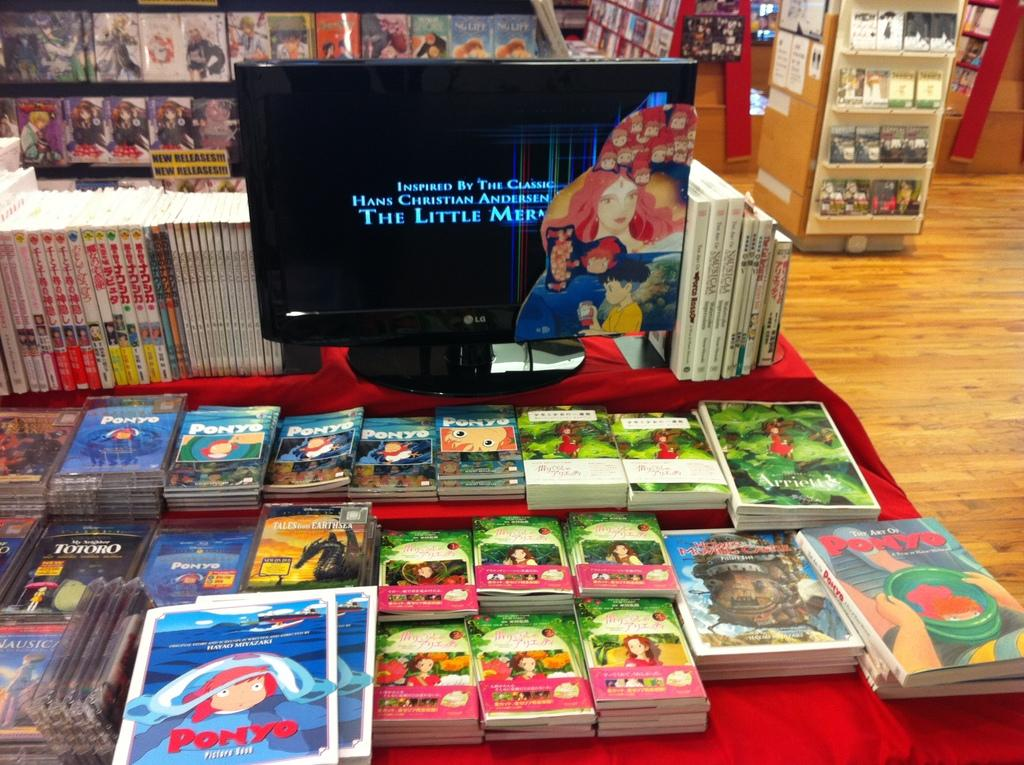<image>
Share a concise interpretation of the image provided. Miyazaki merchandise from some of his movies such as Ponyo 